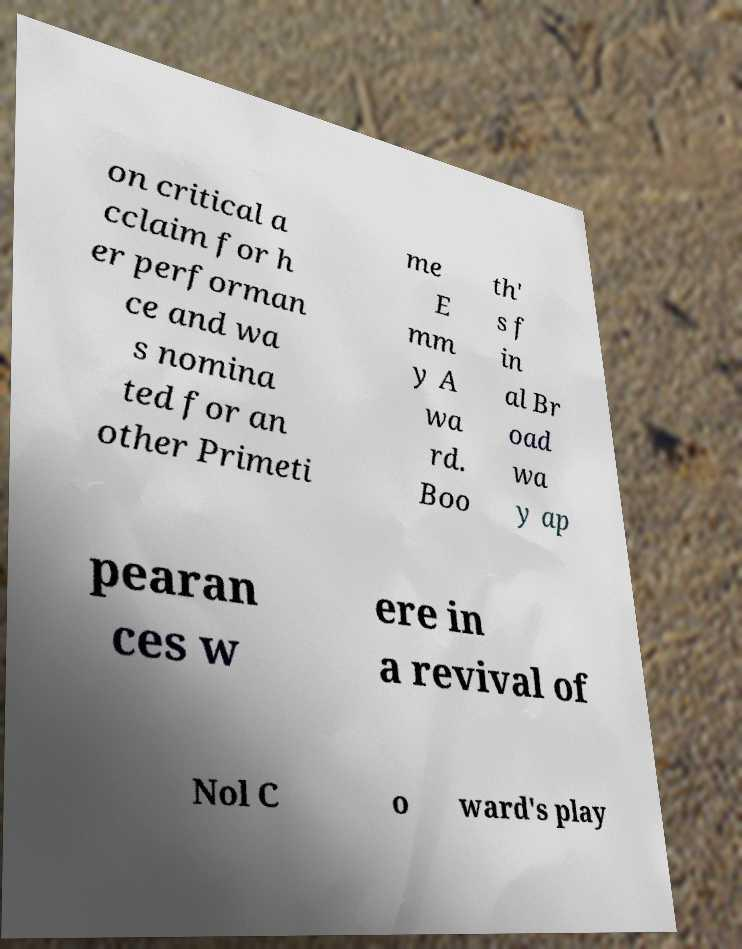Please identify and transcribe the text found in this image. on critical a cclaim for h er performan ce and wa s nomina ted for an other Primeti me E mm y A wa rd. Boo th' s f in al Br oad wa y ap pearan ces w ere in a revival of Nol C o ward's play 